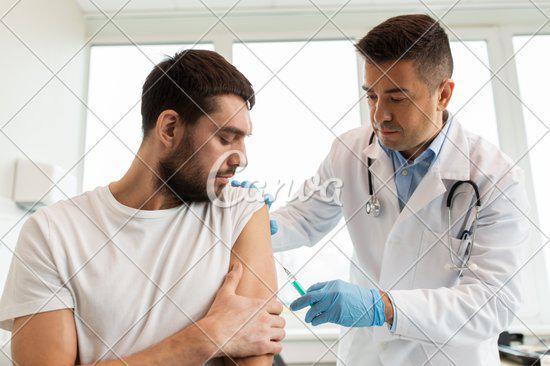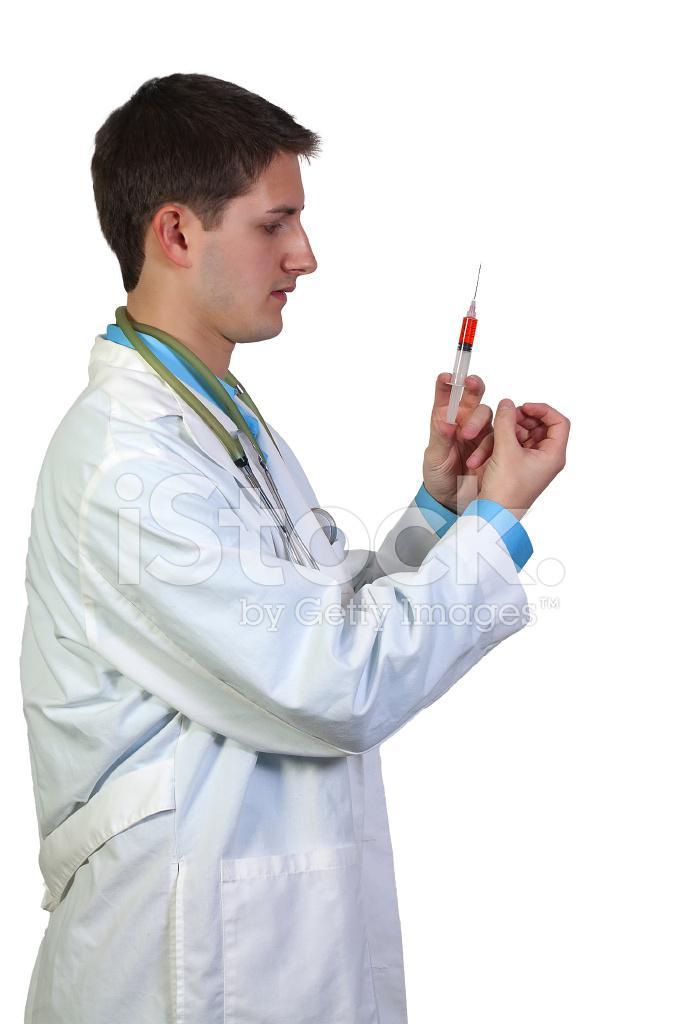The first image is the image on the left, the second image is the image on the right. For the images shown, is this caption "A doctor is looking at a syringe." true? Answer yes or no. Yes. The first image is the image on the left, the second image is the image on the right. Assess this claim about the two images: "A woman is wearing a stethoscope in the image on the right.". Correct or not? Answer yes or no. No. 